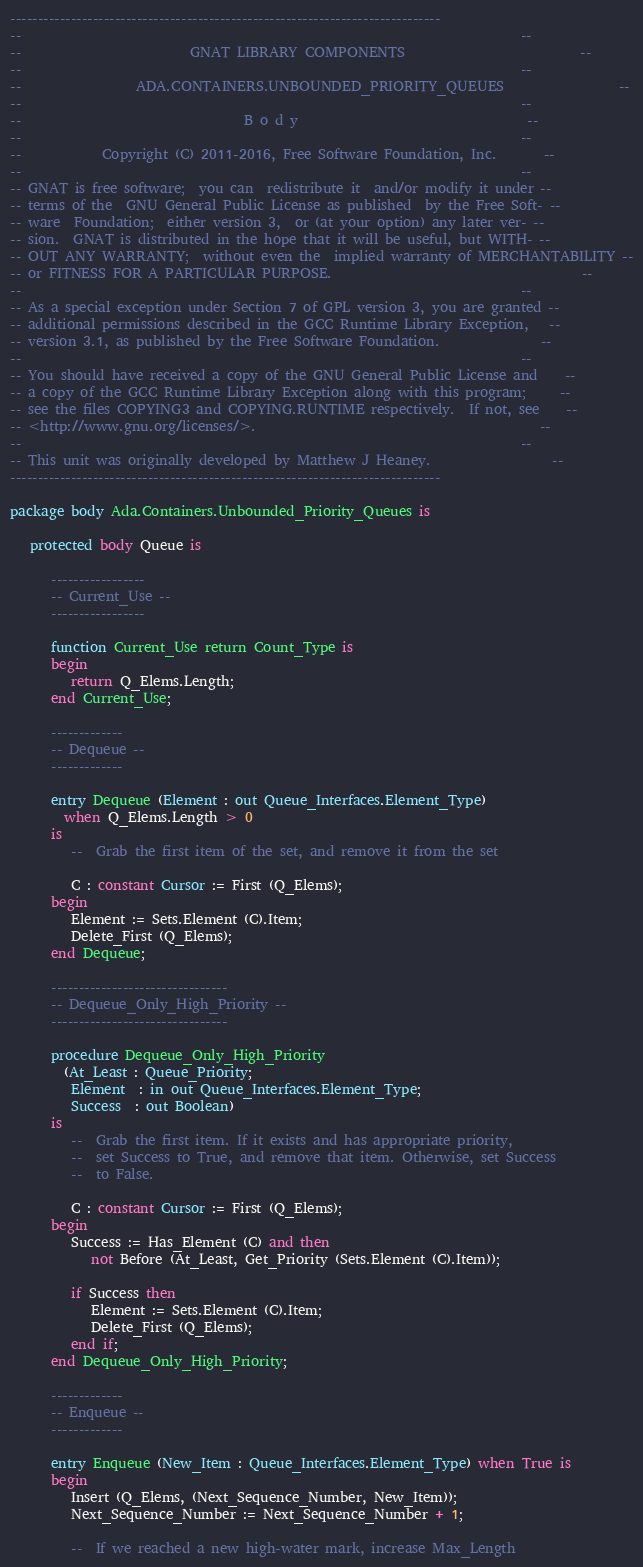Convert code to text. <code><loc_0><loc_0><loc_500><loc_500><_Ada_>------------------------------------------------------------------------------
--                                                                          --
--                         GNAT LIBRARY COMPONENTS                          --
--                                                                          --
--                 ADA.CONTAINERS.UNBOUNDED_PRIORITY_QUEUES                 --
--                                                                          --
--                                 B o d y                                  --
--                                                                          --
--            Copyright (C) 2011-2016, Free Software Foundation, Inc.       --
--                                                                          --
-- GNAT is free software;  you can  redistribute it  and/or modify it under --
-- terms of the  GNU General Public License as published  by the Free Soft- --
-- ware  Foundation;  either version 3,  or (at your option) any later ver- --
-- sion.  GNAT is distributed in the hope that it will be useful, but WITH- --
-- OUT ANY WARRANTY;  without even the  implied warranty of MERCHANTABILITY --
-- or FITNESS FOR A PARTICULAR PURPOSE.                                     --
--                                                                          --
-- As a special exception under Section 7 of GPL version 3, you are granted --
-- additional permissions described in the GCC Runtime Library Exception,   --
-- version 3.1, as published by the Free Software Foundation.               --
--                                                                          --
-- You should have received a copy of the GNU General Public License and    --
-- a copy of the GCC Runtime Library Exception along with this program;     --
-- see the files COPYING3 and COPYING.RUNTIME respectively.  If not, see    --
-- <http://www.gnu.org/licenses/>.                                          --
--                                                                          --
-- This unit was originally developed by Matthew J Heaney.                  --
------------------------------------------------------------------------------

package body Ada.Containers.Unbounded_Priority_Queues is

   protected body Queue is

      -----------------
      -- Current_Use --
      -----------------

      function Current_Use return Count_Type is
      begin
         return Q_Elems.Length;
      end Current_Use;

      -------------
      -- Dequeue --
      -------------

      entry Dequeue (Element : out Queue_Interfaces.Element_Type)
        when Q_Elems.Length > 0
      is
         --  Grab the first item of the set, and remove it from the set

         C : constant Cursor := First (Q_Elems);
      begin
         Element := Sets.Element (C).Item;
         Delete_First (Q_Elems);
      end Dequeue;

      --------------------------------
      -- Dequeue_Only_High_Priority --
      --------------------------------

      procedure Dequeue_Only_High_Priority
        (At_Least : Queue_Priority;
         Element  : in out Queue_Interfaces.Element_Type;
         Success  : out Boolean)
      is
         --  Grab the first item. If it exists and has appropriate priority,
         --  set Success to True, and remove that item. Otherwise, set Success
         --  to False.

         C : constant Cursor := First (Q_Elems);
      begin
         Success := Has_Element (C) and then
            not Before (At_Least, Get_Priority (Sets.Element (C).Item));

         if Success then
            Element := Sets.Element (C).Item;
            Delete_First (Q_Elems);
         end if;
      end Dequeue_Only_High_Priority;

      -------------
      -- Enqueue --
      -------------

      entry Enqueue (New_Item : Queue_Interfaces.Element_Type) when True is
      begin
         Insert (Q_Elems, (Next_Sequence_Number, New_Item));
         Next_Sequence_Number := Next_Sequence_Number + 1;

         --  If we reached a new high-water mark, increase Max_Length
</code> 